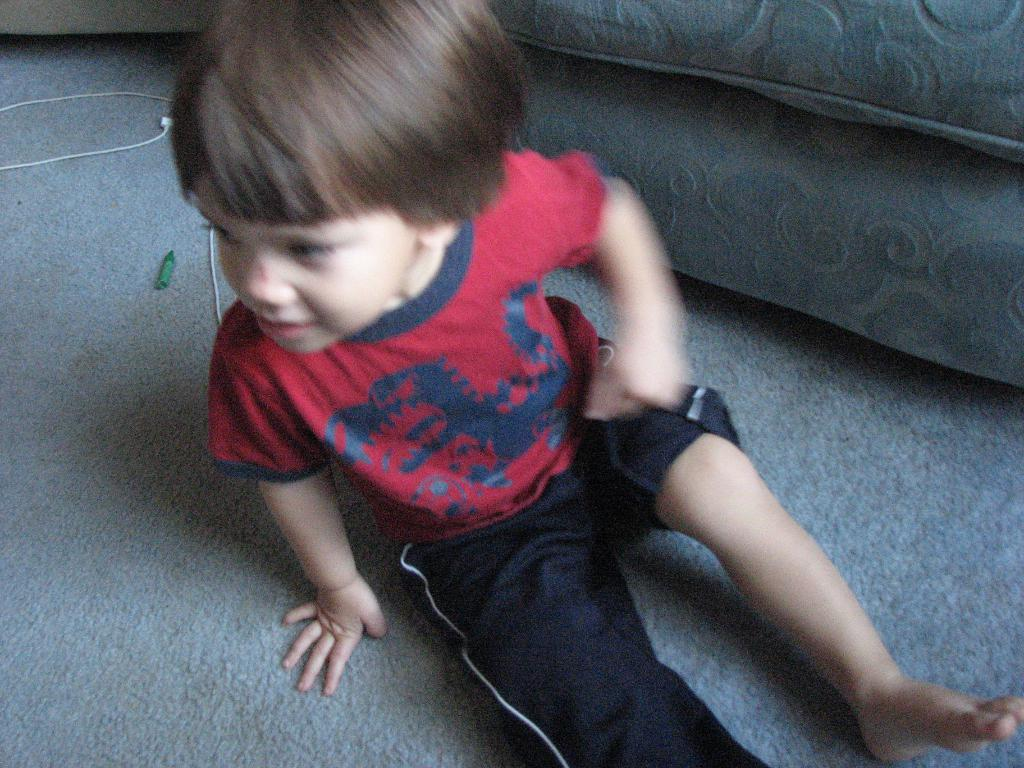What is the main subject of the image? The main subject of the image is a child. What is the child doing in the image? The child is sitting on the floor and smiling. What type of furniture is present in the image? There is a couch present in the image. Can you tell me how many deer are visible in the image? There are no deer present in the image; it features a child sitting on the floor and smiling. What type of worm can be seen crawling on the couch in the image? There are no worms present in the image; the couch is visible but there are no creatures on it. 